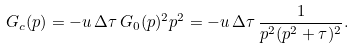<formula> <loc_0><loc_0><loc_500><loc_500>G _ { c } ( p ) = - u \, \Delta \tau \, G _ { 0 } ( p ) ^ { 2 } p ^ { 2 } = - u \, \Delta \tau \, \frac { 1 } { p ^ { 2 } ( p ^ { 2 } + \tau ) ^ { 2 } } .</formula> 